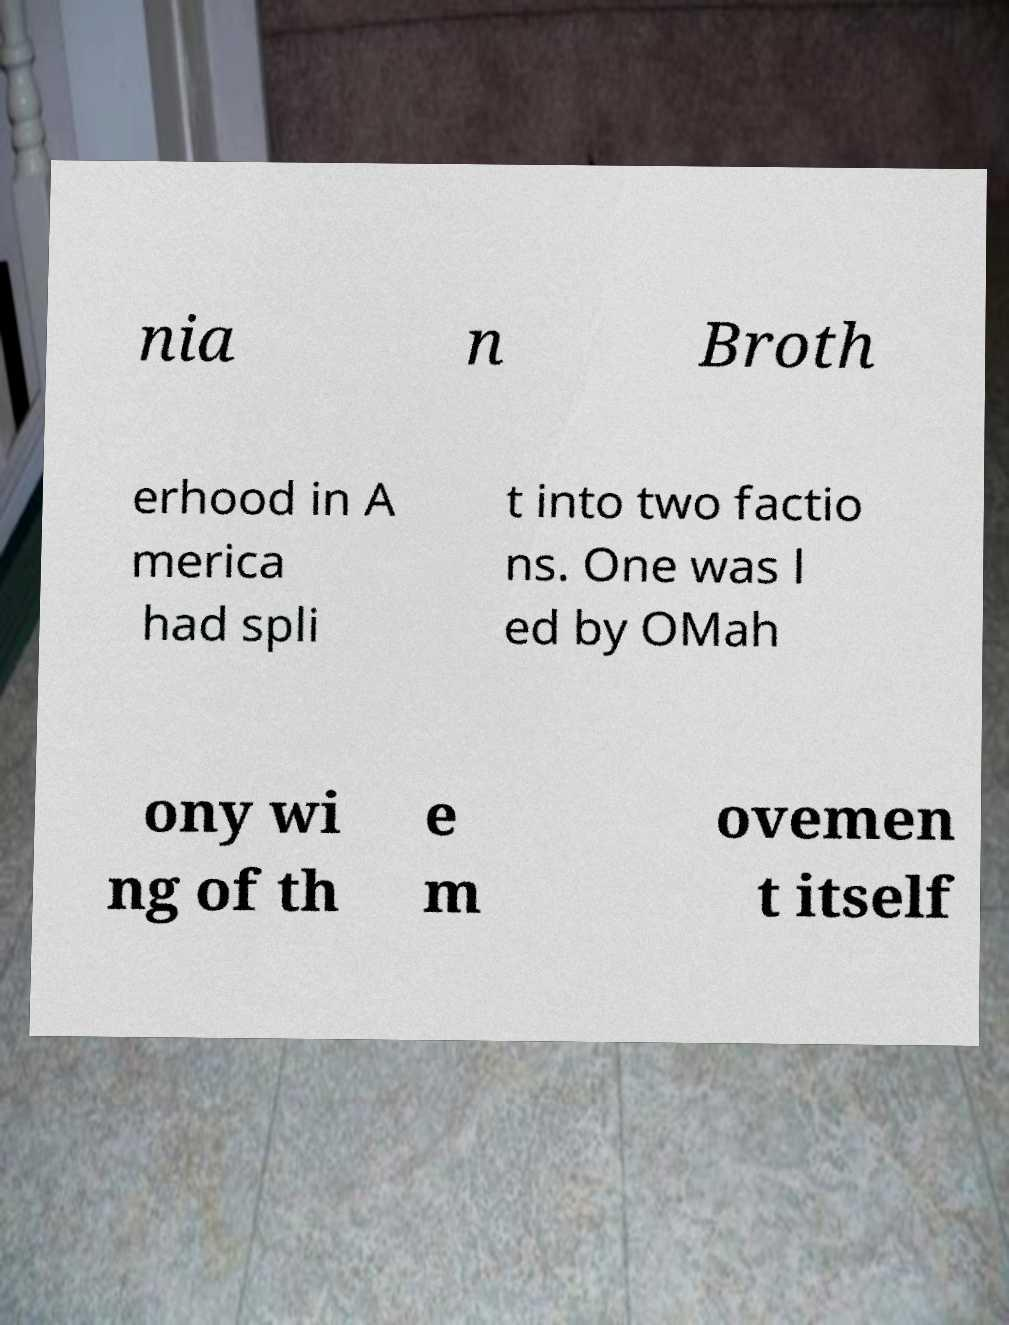Can you accurately transcribe the text from the provided image for me? nia n Broth erhood in A merica had spli t into two factio ns. One was l ed by OMah ony wi ng of th e m ovemen t itself 